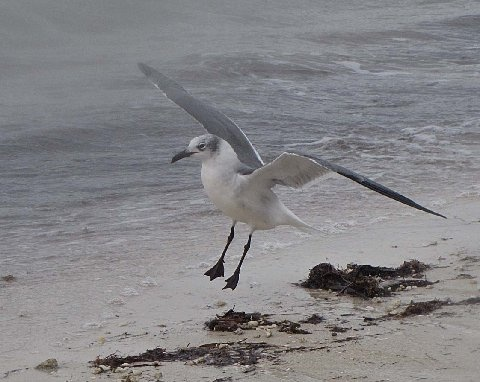Describe the objects in this image and their specific colors. I can see a bird in gray, darkgray, and black tones in this image. 